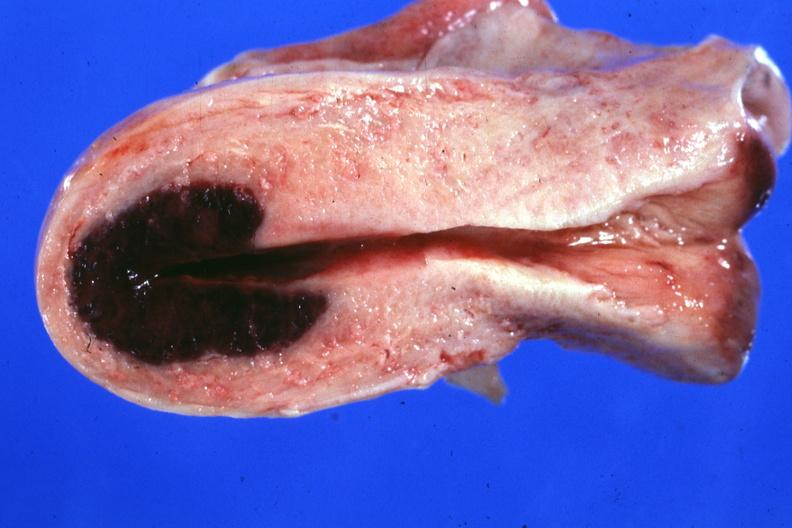what is present?
Answer the question using a single word or phrase. Adenosis and ischemia 